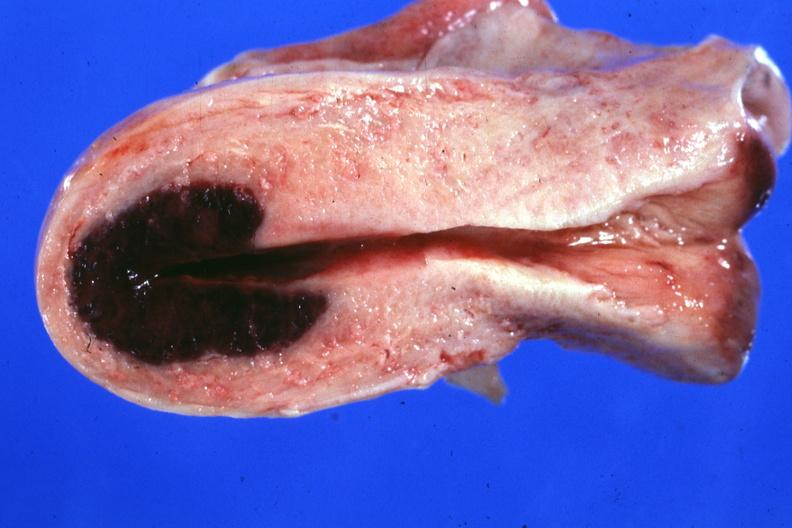what is present?
Answer the question using a single word or phrase. Adenosis and ischemia 